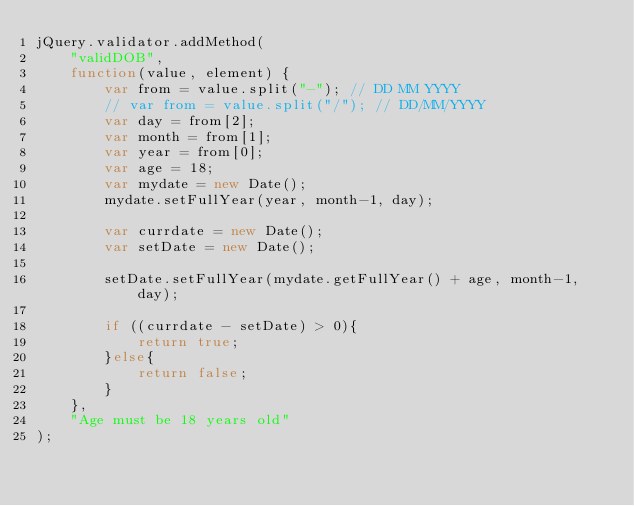<code> <loc_0><loc_0><loc_500><loc_500><_JavaScript_>jQuery.validator.addMethod(
    "validDOB",
    function(value, element) {
        var from = value.split("-"); // DD MM YYYY
        // var from = value.split("/"); // DD/MM/YYYY
        var day = from[2];
        var month = from[1];
        var year = from[0];
        var age = 18;
        var mydate = new Date();
        mydate.setFullYear(year, month-1, day);

        var currdate = new Date();
        var setDate = new Date();

        setDate.setFullYear(mydate.getFullYear() + age, month-1, day);

        if ((currdate - setDate) > 0){
            return true;
        }else{
            return false;
        }
    },
    "Age must be 18 years old"
);
</code> 